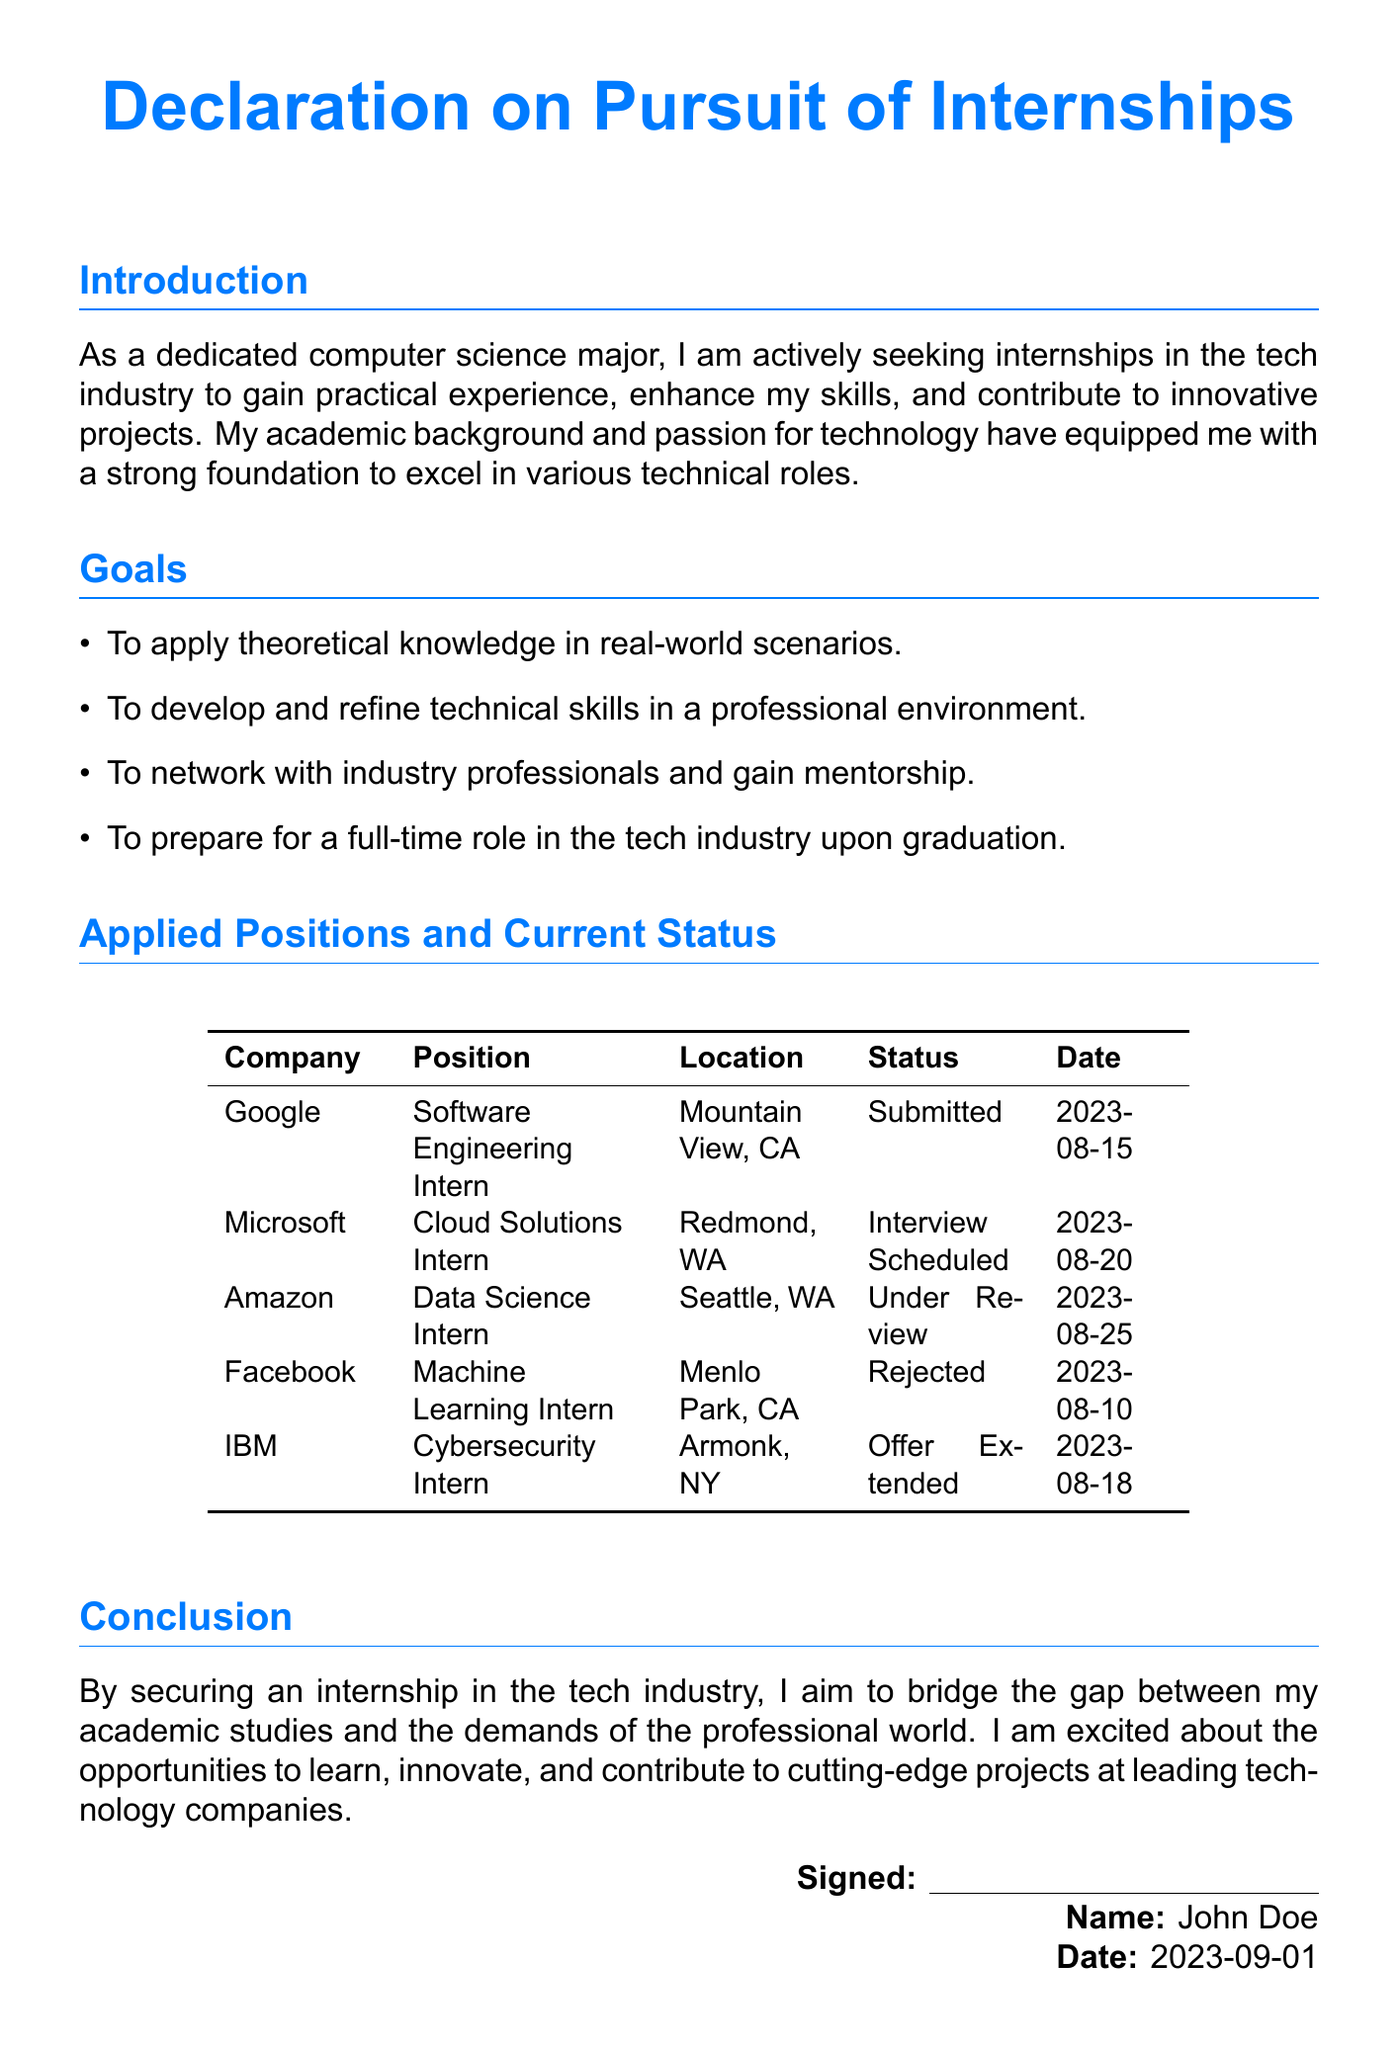What is the name of the student? The name of the student is provided in the signature section of the document.
Answer: John Doe Which company offered an internship position? The document lists all applied positions and their current status, including any offers received.
Answer: IBM What position was applied for at Microsoft? The applied position at Microsoft is specified in the table.
Answer: Cloud Solutions Intern When was the application submitted to Google? The date of submission is noted in the table under the "Date" column for Google.
Answer: 2023-08-15 What is the status of the application to Amazon? The current status of the application is provided in the table, which indicates the review status.
Answer: Under Review What goal involves networking with industry professionals? The goals listed in the document include aspirations as a computer science major, one of which is networking.
Answer: To network with industry professionals and gain mentorship Which company's internship application was rejected? The status table specifies the outcome of the applications, including rejections.
Answer: Facebook How many internship positions were applied to? The total number of positions listed in the applied positions section provides this information.
Answer: 5 